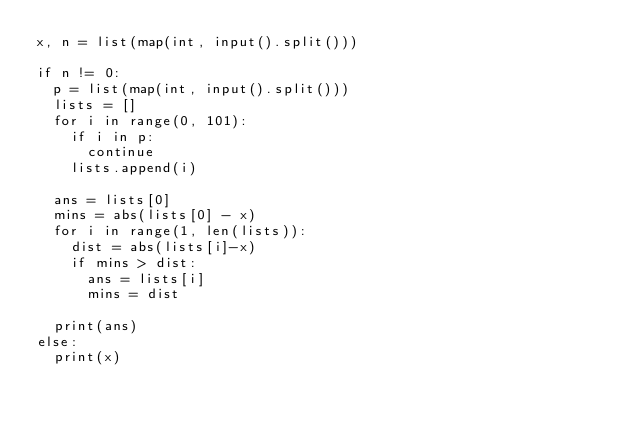Convert code to text. <code><loc_0><loc_0><loc_500><loc_500><_Python_>x, n = list(map(int, input().split()))

if n != 0:
  p = list(map(int, input().split()))
  lists = []
  for i in range(0, 101):
    if i in p:
      continue
    lists.append(i)

  ans = lists[0]
  mins = abs(lists[0] - x)
  for i in range(1, len(lists)):
    dist = abs(lists[i]-x)
    if mins > dist:
      ans = lists[i]
      mins = dist
      
  print(ans)
else:
  print(x)</code> 